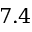<formula> <loc_0><loc_0><loc_500><loc_500>7 . 4</formula> 